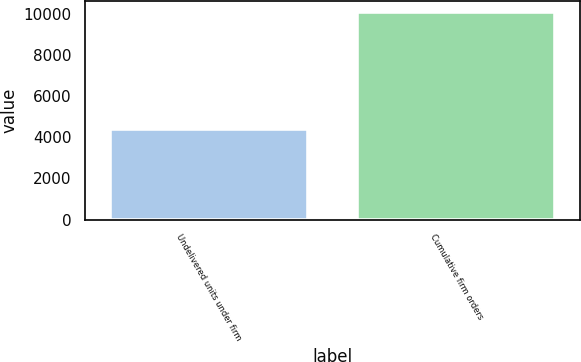<chart> <loc_0><loc_0><loc_500><loc_500><bar_chart><fcel>Undelivered units under firm<fcel>Cumulative firm orders<nl><fcel>4392<fcel>10105<nl></chart> 